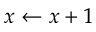Convert formula to latex. <formula><loc_0><loc_0><loc_500><loc_500>x \gets x + 1</formula> 